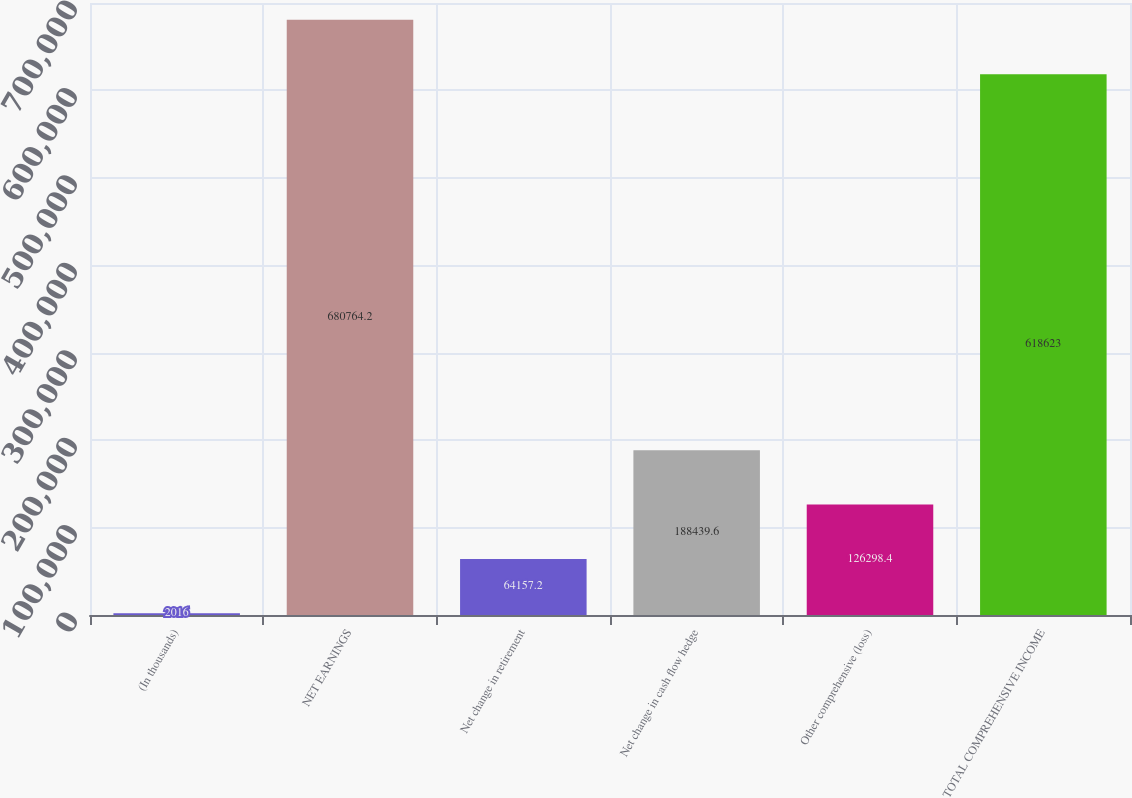Convert chart. <chart><loc_0><loc_0><loc_500><loc_500><bar_chart><fcel>(In thousands)<fcel>NET EARNINGS<fcel>Net change in retirement<fcel>Net change in cash flow hedge<fcel>Other comprehensive (loss)<fcel>TOTAL COMPREHENSIVE INCOME<nl><fcel>2016<fcel>680764<fcel>64157.2<fcel>188440<fcel>126298<fcel>618623<nl></chart> 